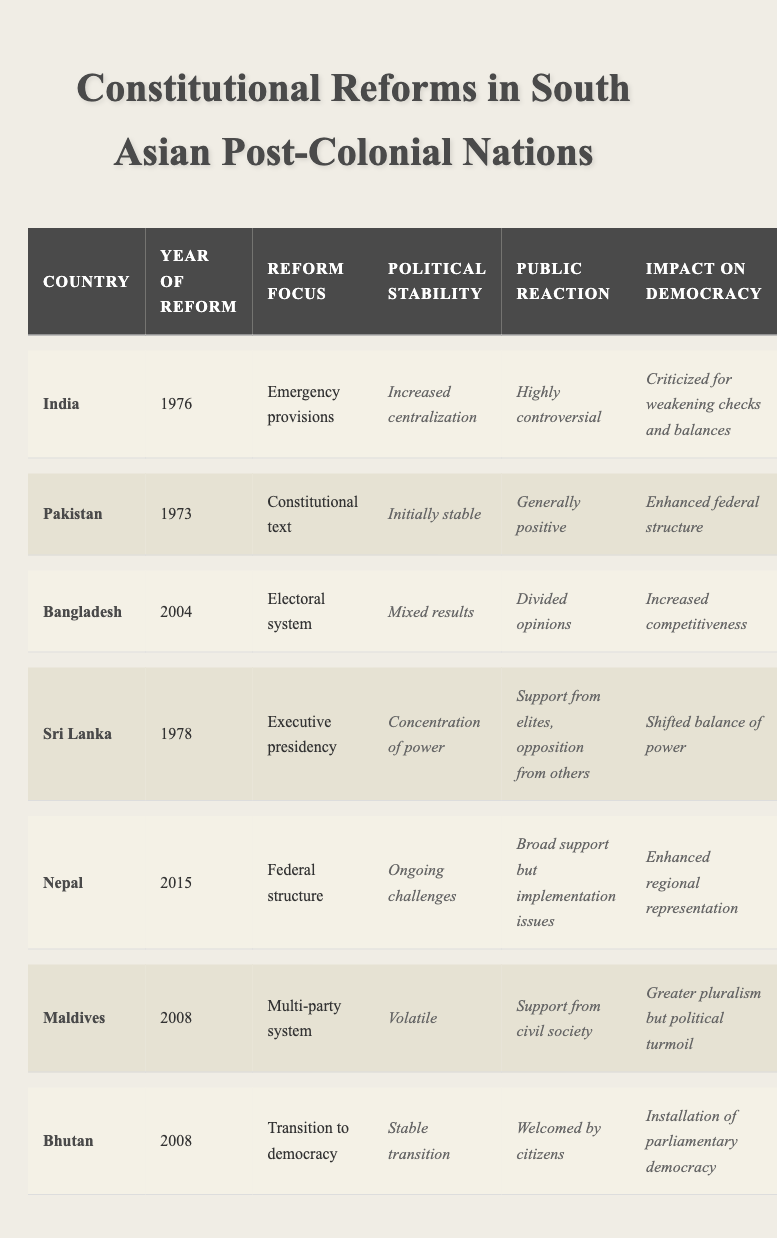What year did India implement constitutional reform? According to the table, India reformed its constitution in 1976.
Answer: 1976 What was the reform focus of the constitutional reform in Pakistan? The table indicates that Pakistan focused on the constitutional text during its reform in 1973.
Answer: Constitutional text Which country experienced a stable transition to democracy in 2008? Bhutan is listed in the table as having a stable transition to democracy in 2008.
Answer: Bhutan What was the public reaction to the electoral system reform in Bangladesh? The table shows that the public reaction to the electoral system reform in Bangladesh was divided opinions.
Answer: Divided opinions What is the impact on democracy as a result of the reform in Nepal? The impact on democracy in Nepal is noted as enhanced regional representation.
Answer: Enhanced regional representation Did Maldives' 2008 reform lead to greater political stability? The table states that Maldives' political stability post-reform was volatile, indicating instability rather than stability.
Answer: No Which country had a generally positive public reaction to its constitutional reform? The table indicates that Pakistan had a generally positive public reaction to its constitutional reform in 1973.
Answer: Pakistan Which two countries implemented reforms that focused on the executive structure in the late 1970s? The table lists India’s focus on emergency provisions in 1976 and Sri Lanka’s focus on the executive presidency in 1978, both in the late 1970s.
Answer: India and Sri Lanka What was the political stability outcome of the constitutional reform in Sri Lanka? The reform in Sri Lanka led to a concentration of power, according to the table.
Answer: Concentration of power How did the impact on democracy differ between the reforms in India and Nepal? India’s reform weakened checks and balances, while Nepal's reform enhanced regional representation, showing a contrast in democratic impacts.
Answer: Different impacts How many countries experienced a positive public reaction towards their constitutional reforms? By reviewing the table, Pakistan and Bhutan had positive public reactions, totaling 2 countries.
Answer: 2 countries 